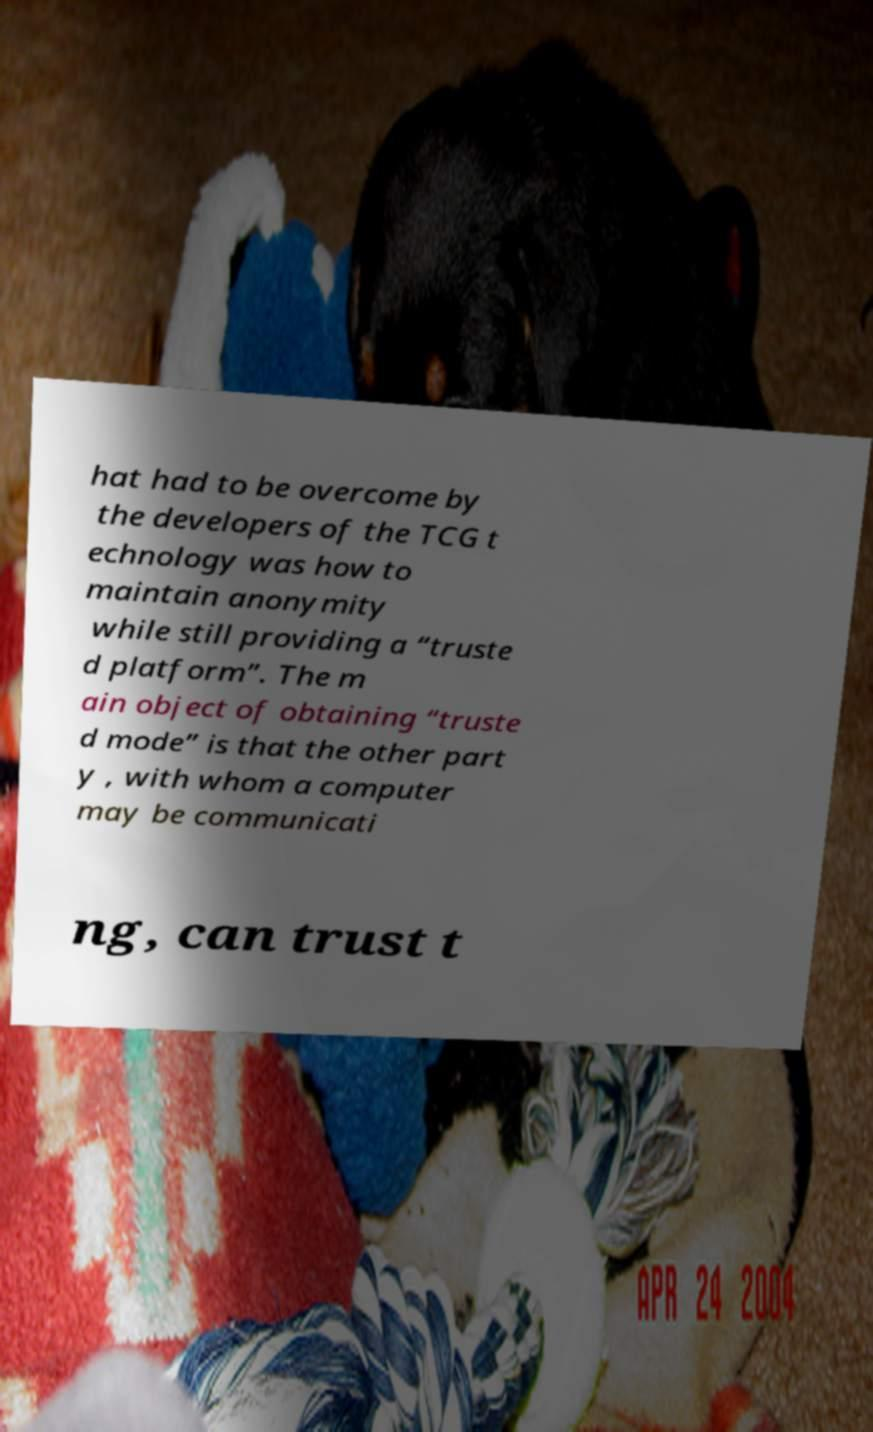Can you accurately transcribe the text from the provided image for me? hat had to be overcome by the developers of the TCG t echnology was how to maintain anonymity while still providing a “truste d platform”. The m ain object of obtaining “truste d mode” is that the other part y , with whom a computer may be communicati ng, can trust t 